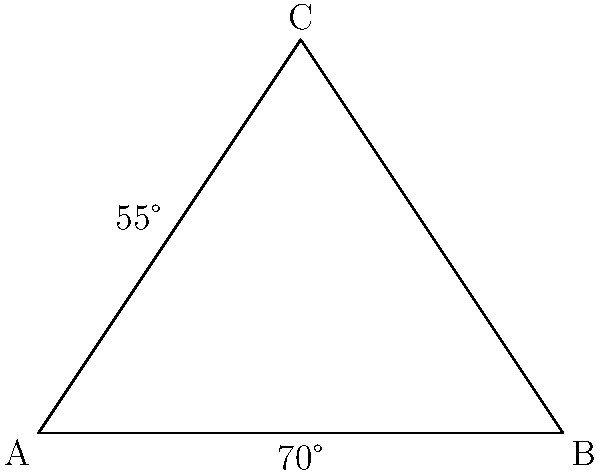In an esports game, the field of view (FOV) is represented by the angle ACB in the diagram. If angle CAB is 55° and angle ABC is 70°, calculate the FOV angle ACB to optimize your in-game camera settings. To find the FOV angle ACB, we can follow these steps:

1) In any triangle, the sum of all interior angles is always 180°.

2) We are given two angles of the triangle:
   Angle CAB = 55°
   Angle ABC = 70°

3) Let's call the FOV angle ACB as x°.

4) Using the triangle angle sum theorem:
   $$55° + 70° + x° = 180°$$

5) Simplify:
   $$125° + x° = 180°$$

6) Subtract 125° from both sides:
   $$x° = 180° - 125°$$

7) Solve for x:
   $$x = 55°$$

Therefore, the FOV angle ACB is 55°.
Answer: 55° 